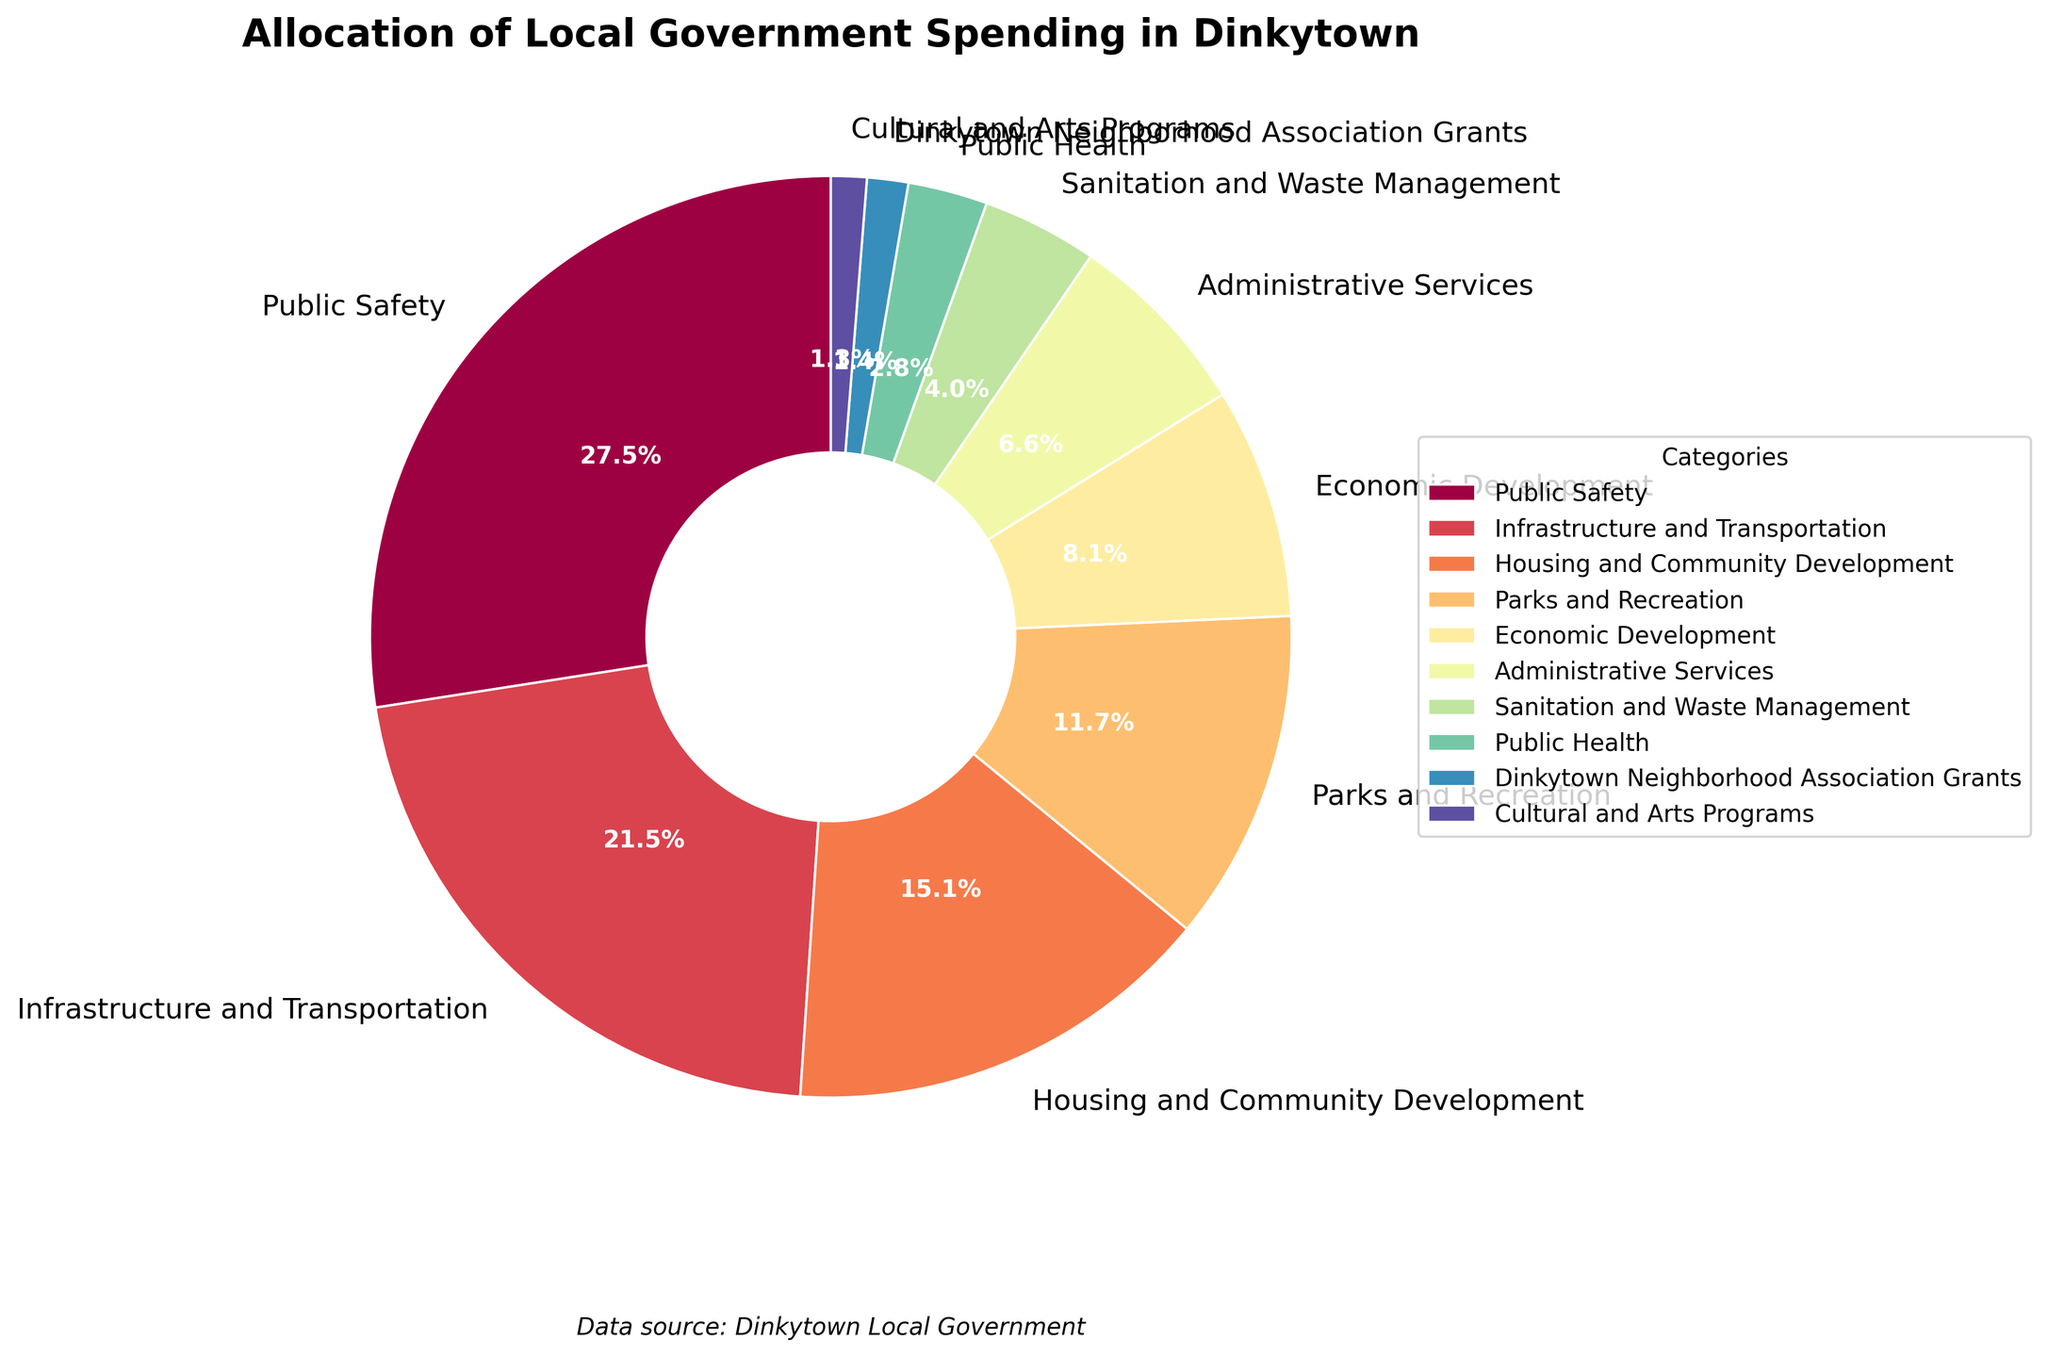What percentage of spending is allocated to Public Safety? The pie chart shows a labeled percentage for each category. For Public Safety, the label is 28.5%.
Answer: 28.5% Which category receives a higher percentage of spending, Parks and Recreation or Housing and Community Development? From the pie chart, Parks and Recreation receives 12.1% of spending, while Housing and Community Development receives 15.7%. Comparing these two values, Housing and Community Development receives a higher percentage.
Answer: Housing and Community Development What is the combined percentage of spending on Sanitation and Waste Management and Public Health? The pie chart shows that Sanitation and Waste Management receives 4.2% and Public Health receives 2.9%. Adding these two percentages: 4.2% + 2.9% = 7.1%.
Answer: 7.1% Is Infrastructure and Transportation allocated more than twice the percentage compared to Economic Development? Infrastructure and Transportation has 22.3% and Economic Development has 8.4%. Twice the percentage of Economic Development is 8.4% * 2 = 16.8%. Since 22.3% is greater than 16.8%, the statement is true.
Answer: Yes What fraction of the total spending is allocated to Administrative Services? The pie chart shows that Administrative Services receives 6.9% of the total spending. Converting this percentage to a fraction: 6.9/100 = 0.069.
Answer: 0.069 Which category receives the least amount of spending? From the pie chart, Cultural and Arts Programs receives 1.3%, which is the smallest percentage among all categories.
Answer: Cultural and Arts Programs By how much does the percentage for Public Safety exceed the combined percentages for Dinkytown Neighborhood Association Grants and Cultural and Arts Programs? Public Safety has 28.5%. Dinkytown Neighborhood Association Grants and Cultural and Arts Programs together have 1.5% + 1.3% = 2.8%. The difference is 28.5% - 2.8% = 25.7%.
Answer: 25.7% What is the most dominant color visible in the largest wedge? The largest wedge represents Public Safety, which occupies the largest area. The most dominant color visually for this wedge, based on the custom color palette provided, is a deep shade that appears prominently in the chart.
Answer: Deep shade (likely orange or red based on usual Spectral palette) Is the spending on Economic Development higher than that on Parks and Recreation? Economic Development receives 8.4% which is less compared to Parks and Recreation's 12.1%.
Answer: No What is the combined percentage of the three least funded categories? The percentages for the three least funded categories are Dinkytown Neighborhood Association Grants (1.5%), Cultural and Arts Programs (1.3%), and Public Health (2.9%). Adding these gives: 1.5% + 1.3% + 2.9% = 5.7%.
Answer: 5.7% 